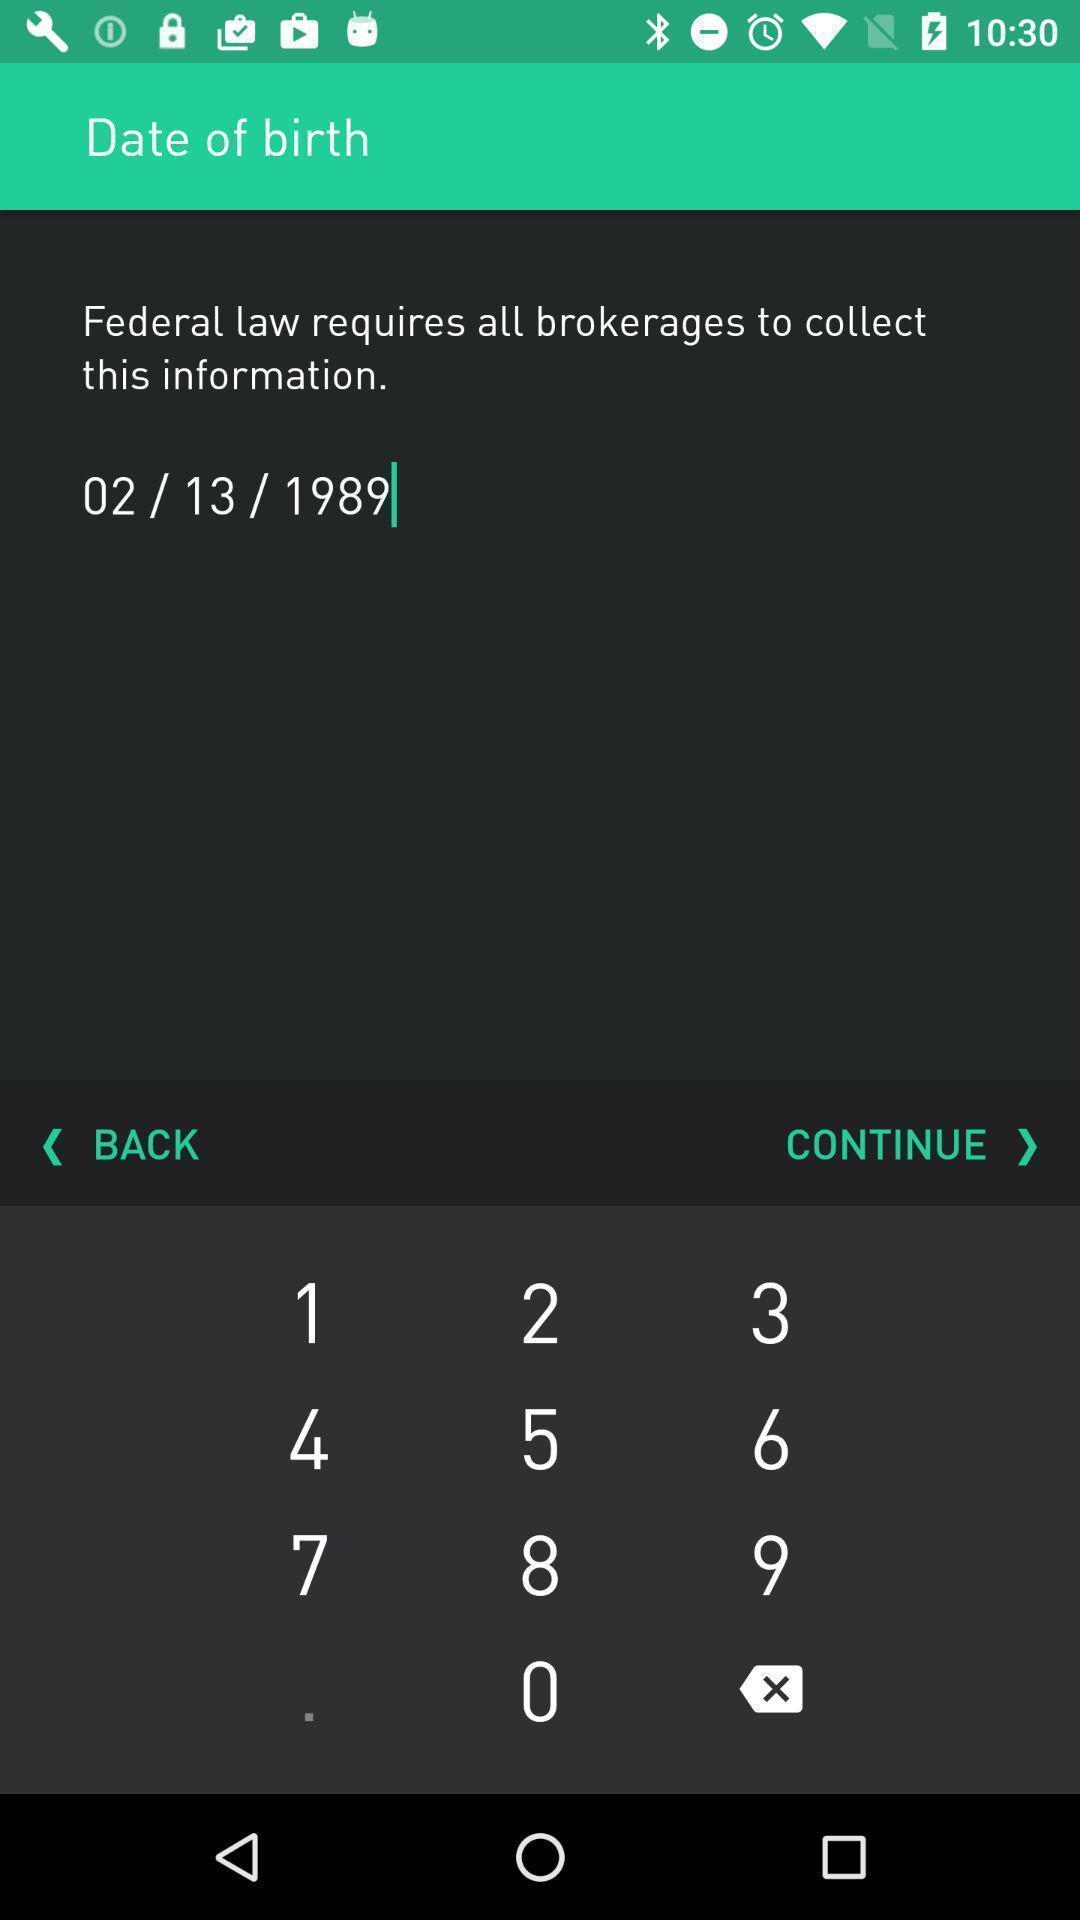What details can you identify in this image? Page with a keypad to enter birth information. 